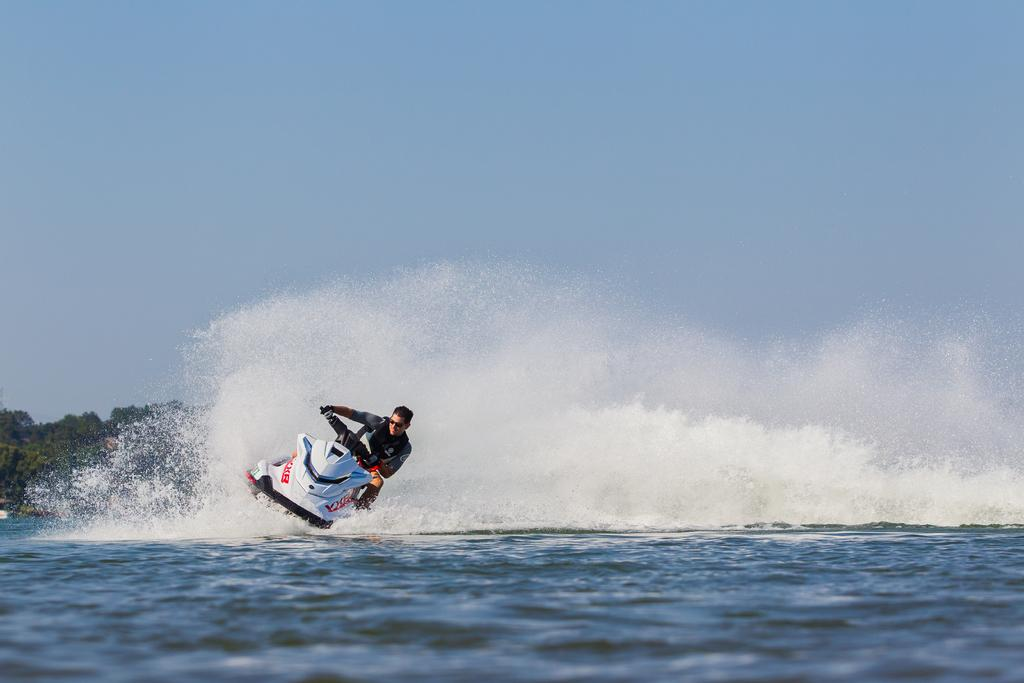What is the main setting of the image? The image depicts a sea. What activity is the person in the image engaged in? There is a person riding a water bike on the water. What type of vegetation can be seen in the background? There are trees visible in the background. What is visible at the top of the image? The sky is visible at the top of the image. What makes up the majority of the image? Water is present at the bottom of the image. What type of scarf is the creature wearing in the image? There is no creature present in the image, and therefore no scarf or any other clothing item can be observed. 